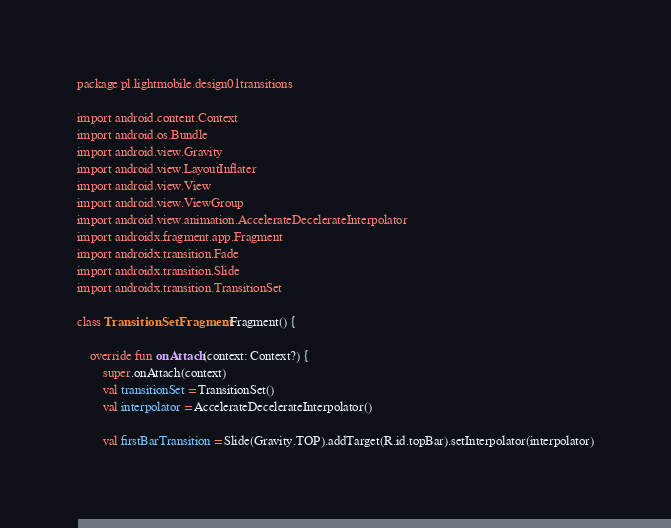Convert code to text. <code><loc_0><loc_0><loc_500><loc_500><_Kotlin_>package pl.lightmobile.design01transitions

import android.content.Context
import android.os.Bundle
import android.view.Gravity
import android.view.LayoutInflater
import android.view.View
import android.view.ViewGroup
import android.view.animation.AccelerateDecelerateInterpolator
import androidx.fragment.app.Fragment
import androidx.transition.Fade
import androidx.transition.Slide
import androidx.transition.TransitionSet

class TransitionSetFragment : Fragment() {

    override fun onAttach(context: Context?) {
        super.onAttach(context)
        val transitionSet = TransitionSet()
        val interpolator = AccelerateDecelerateInterpolator()

        val firstBarTransition = Slide(Gravity.TOP).addTarget(R.id.topBar).setInterpolator(interpolator)</code> 